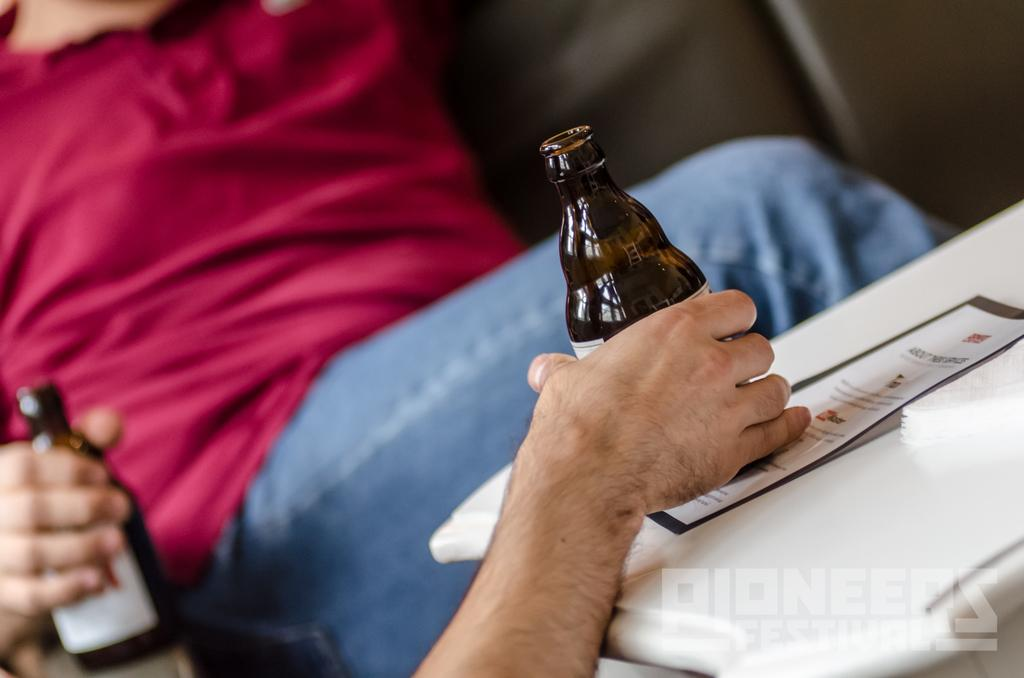What is being held by the hands in the image? There are hands holding bottles in the image. What else can be seen in the image besides the hands and bottles? There is a paper visible in the image. What type of vessel is being used by the father in the image? There is no father or vessel present in the image; it only shows hands holding bottles and a paper. 